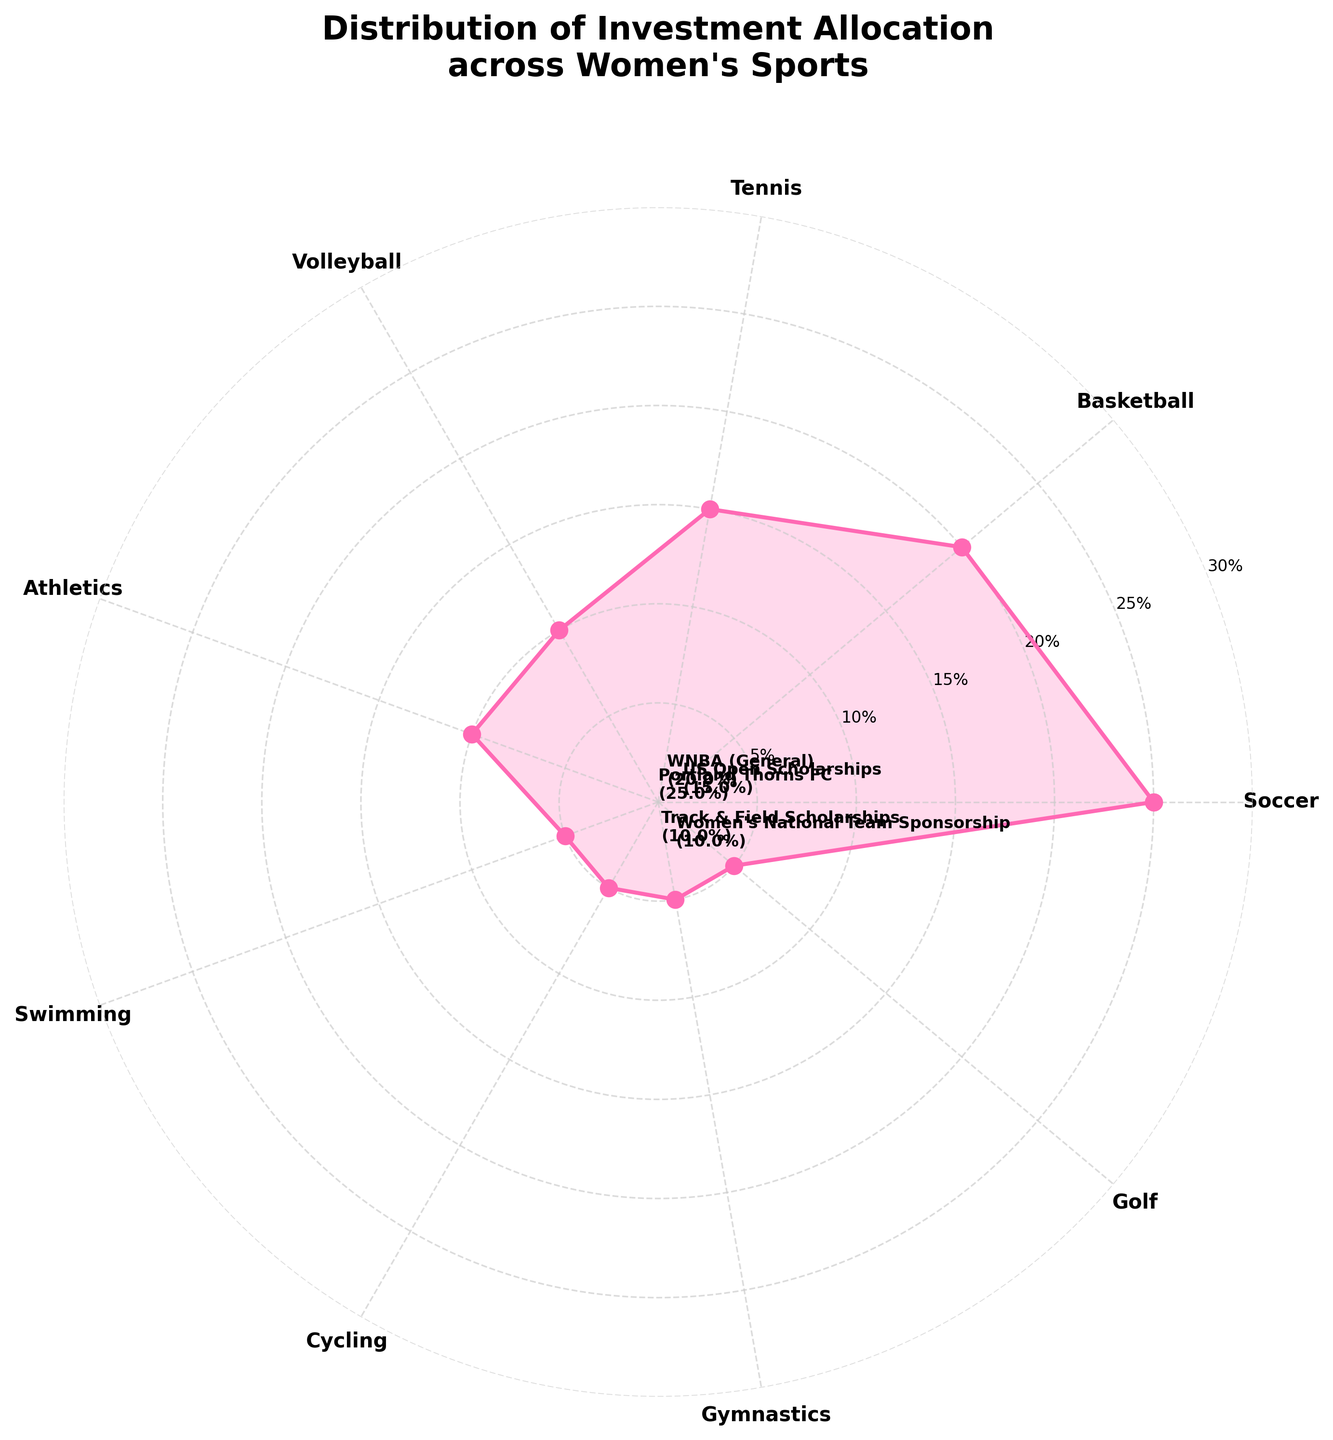What is the title of the figure? The title of the figure is usually displayed at the top of the plot in a larger and bold font to convey the main message of the chart. Just refer to the top of the plot.
Answer: Distribution of Investment Allocation across Women's Sports How many sports are displayed in the figure? Count the number of unique categories displayed around the polar plot. Each sector represents one sport.
Answer: 9 Which sport receives the largest percentage of investment? Identify the sector with the highest value on the radial axis. It will likely be the one extending the furthest from the center.
Answer: Soccer Which sport receives the least percentage of investment? Identify the sector with the smallest value on the radial axis. It is the one closest to the center of the plot.
Answer: Swimming, Cycling, Gymnastics, Golf (each 5%) What is the combined investment percentage for Soccer and Basketball? Find the percentages for Soccer and Basketball and add them together. Soccer is 25%, and Basketball is 20%. So, 25% + 20%.
Answer: 45% Which team or scholarship is associated with Volleyball? Look at the annotations around the plot and find the one associated with Volleyball. It will indicate the corresponding team or scholarship.
Answer: Women's National Team Sponsorship How many sports receive an investment percentage of 10% or more? Count the number of sectors that have percentages of 10% or higher.
Answer: 5 Compare the investment allocation between Athletics and Swimming. Which one gets more, and by how much? Find the percentages for Athletics and Swimming. Athletics is 10%, and Swimming is 5%. Subtract the smaller value from the bigger one: 10% - 5%.
Answer: Athletics gets 5% more What is the median investment allocation percentage among the sports? List all the percentages: [25, 20, 15, 10, 10, 5, 5, 5, 5] and find the middle value. Since there are 9 values, the middle one is the 5th value when sorted.
Answer: 10% Which sport is located directly opposite Soccer on the polar chart? View the chart and look at the angle that is directly opposite Soccer. Identify the sport placed there.
Answer: Cycling 